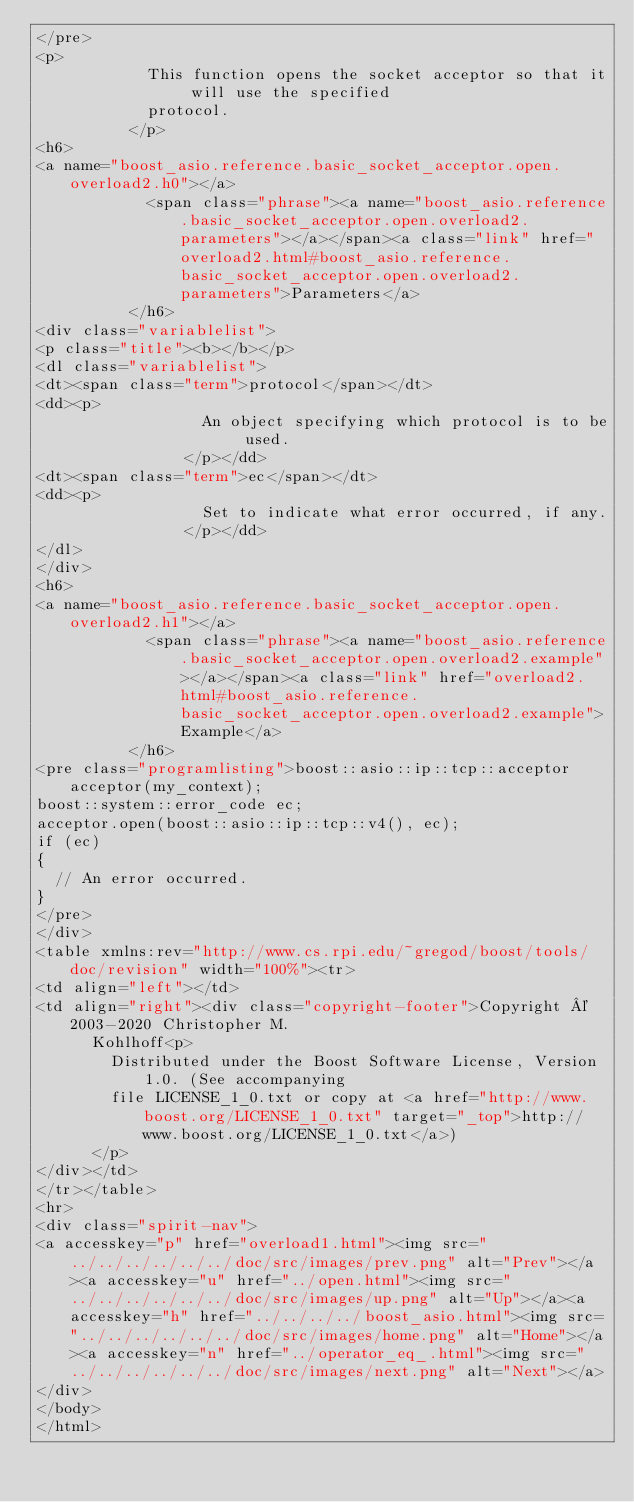Convert code to text. <code><loc_0><loc_0><loc_500><loc_500><_HTML_></pre>
<p>
            This function opens the socket acceptor so that it will use the specified
            protocol.
          </p>
<h6>
<a name="boost_asio.reference.basic_socket_acceptor.open.overload2.h0"></a>
            <span class="phrase"><a name="boost_asio.reference.basic_socket_acceptor.open.overload2.parameters"></a></span><a class="link" href="overload2.html#boost_asio.reference.basic_socket_acceptor.open.overload2.parameters">Parameters</a>
          </h6>
<div class="variablelist">
<p class="title"><b></b></p>
<dl class="variablelist">
<dt><span class="term">protocol</span></dt>
<dd><p>
                  An object specifying which protocol is to be used.
                </p></dd>
<dt><span class="term">ec</span></dt>
<dd><p>
                  Set to indicate what error occurred, if any.
                </p></dd>
</dl>
</div>
<h6>
<a name="boost_asio.reference.basic_socket_acceptor.open.overload2.h1"></a>
            <span class="phrase"><a name="boost_asio.reference.basic_socket_acceptor.open.overload2.example"></a></span><a class="link" href="overload2.html#boost_asio.reference.basic_socket_acceptor.open.overload2.example">Example</a>
          </h6>
<pre class="programlisting">boost::asio::ip::tcp::acceptor acceptor(my_context);
boost::system::error_code ec;
acceptor.open(boost::asio::ip::tcp::v4(), ec);
if (ec)
{
  // An error occurred.
}
</pre>
</div>
<table xmlns:rev="http://www.cs.rpi.edu/~gregod/boost/tools/doc/revision" width="100%"><tr>
<td align="left"></td>
<td align="right"><div class="copyright-footer">Copyright © 2003-2020 Christopher M.
      Kohlhoff<p>
        Distributed under the Boost Software License, Version 1.0. (See accompanying
        file LICENSE_1_0.txt or copy at <a href="http://www.boost.org/LICENSE_1_0.txt" target="_top">http://www.boost.org/LICENSE_1_0.txt</a>)
      </p>
</div></td>
</tr></table>
<hr>
<div class="spirit-nav">
<a accesskey="p" href="overload1.html"><img src="../../../../../../doc/src/images/prev.png" alt="Prev"></a><a accesskey="u" href="../open.html"><img src="../../../../../../doc/src/images/up.png" alt="Up"></a><a accesskey="h" href="../../../../boost_asio.html"><img src="../../../../../../doc/src/images/home.png" alt="Home"></a><a accesskey="n" href="../operator_eq_.html"><img src="../../../../../../doc/src/images/next.png" alt="Next"></a>
</div>
</body>
</html>
</code> 